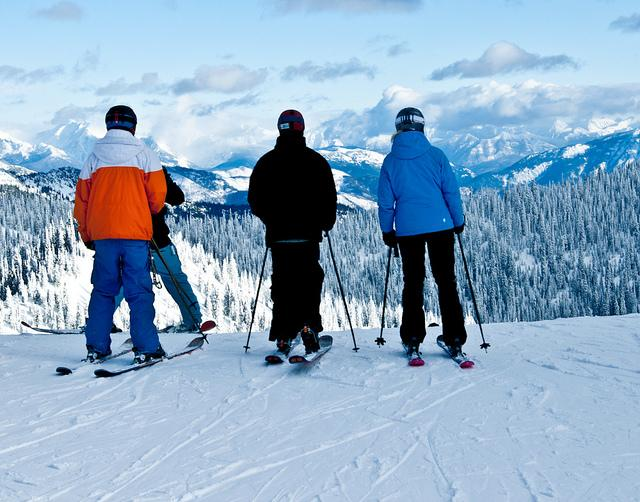What are the people surrounded by? snow 